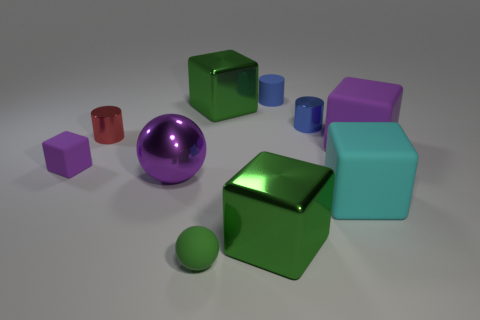Is there anything else that has the same color as the matte sphere?
Keep it short and to the point. Yes. How big is the purple object that is both to the left of the small green object and to the right of the tiny red thing?
Your answer should be very brief. Large. There is a rubber object on the right side of the big cyan rubber thing; is it the same color as the big ball in front of the big purple block?
Make the answer very short. Yes. There is a large metallic object that is in front of the red object and right of the small green object; what is its shape?
Offer a very short reply. Cube. There is a small cube; is its color the same as the matte cube behind the tiny purple cube?
Your response must be concise. Yes. Is the size of the purple object that is on the right side of the matte ball the same as the small green thing?
Give a very brief answer. No. What material is the other small thing that is the same shape as the purple metal thing?
Provide a succinct answer. Rubber. Is the shape of the green rubber thing the same as the large purple shiny thing?
Offer a very short reply. Yes. There is a small shiny cylinder behind the red metal object; what number of small green matte objects are to the right of it?
Ensure brevity in your answer.  0. The big purple object that is made of the same material as the green ball is what shape?
Ensure brevity in your answer.  Cube. 